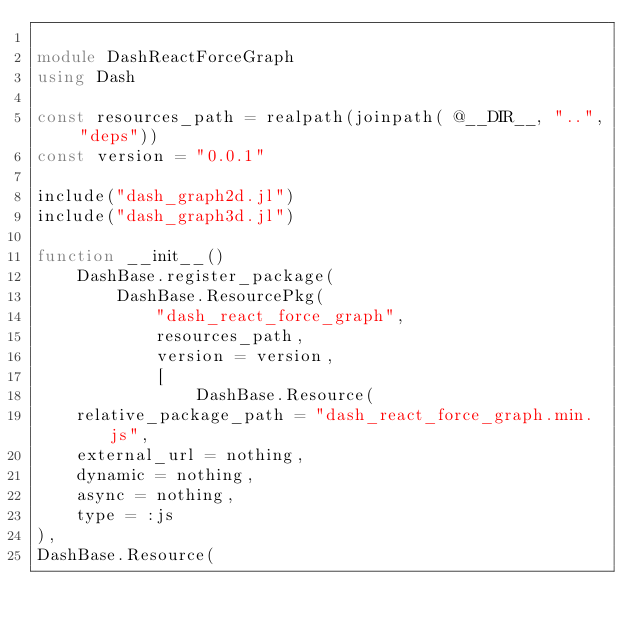<code> <loc_0><loc_0><loc_500><loc_500><_Julia_>
module DashReactForceGraph
using Dash

const resources_path = realpath(joinpath( @__DIR__, "..", "deps"))
const version = "0.0.1"

include("dash_graph2d.jl")
include("dash_graph3d.jl")

function __init__()
    DashBase.register_package(
        DashBase.ResourcePkg(
            "dash_react_force_graph",
            resources_path,
            version = version,
            [
                DashBase.Resource(
    relative_package_path = "dash_react_force_graph.min.js",
    external_url = nothing,
    dynamic = nothing,
    async = nothing,
    type = :js
),
DashBase.Resource(</code> 